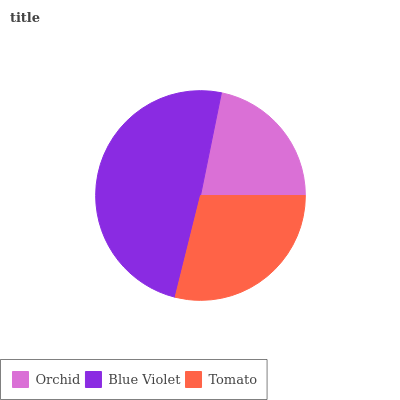Is Orchid the minimum?
Answer yes or no. Yes. Is Blue Violet the maximum?
Answer yes or no. Yes. Is Tomato the minimum?
Answer yes or no. No. Is Tomato the maximum?
Answer yes or no. No. Is Blue Violet greater than Tomato?
Answer yes or no. Yes. Is Tomato less than Blue Violet?
Answer yes or no. Yes. Is Tomato greater than Blue Violet?
Answer yes or no. No. Is Blue Violet less than Tomato?
Answer yes or no. No. Is Tomato the high median?
Answer yes or no. Yes. Is Tomato the low median?
Answer yes or no. Yes. Is Blue Violet the high median?
Answer yes or no. No. Is Orchid the low median?
Answer yes or no. No. 